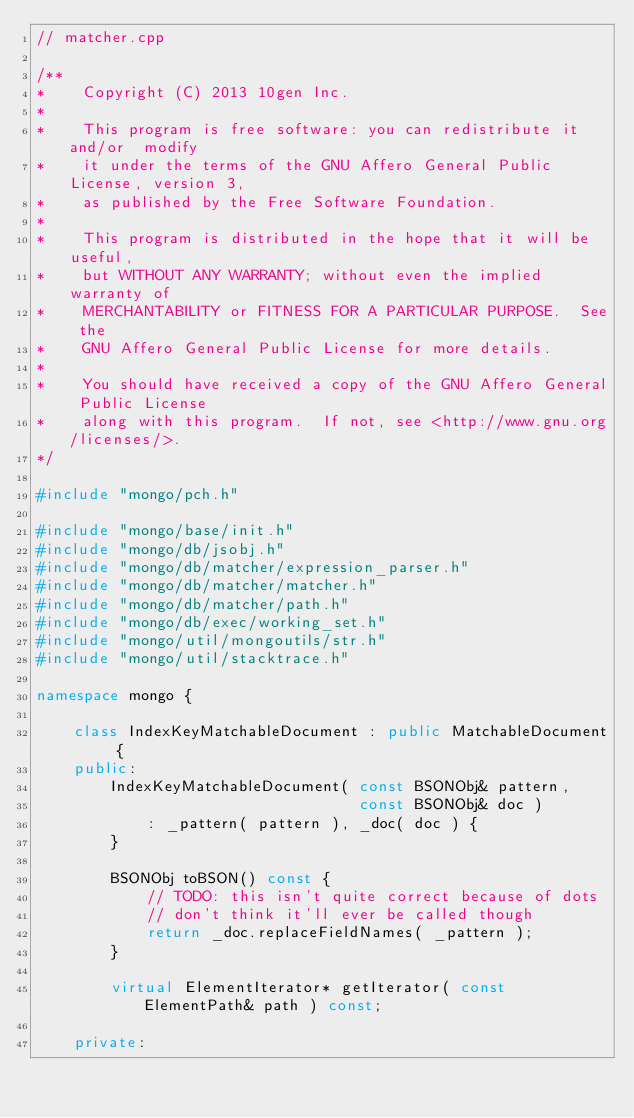<code> <loc_0><loc_0><loc_500><loc_500><_C++_>// matcher.cpp

/**
*    Copyright (C) 2013 10gen Inc.
*
*    This program is free software: you can redistribute it and/or  modify
*    it under the terms of the GNU Affero General Public License, version 3,
*    as published by the Free Software Foundation.
*
*    This program is distributed in the hope that it will be useful,
*    but WITHOUT ANY WARRANTY; without even the implied warranty of
*    MERCHANTABILITY or FITNESS FOR A PARTICULAR PURPOSE.  See the
*    GNU Affero General Public License for more details.
*
*    You should have received a copy of the GNU Affero General Public License
*    along with this program.  If not, see <http://www.gnu.org/licenses/>.
*/

#include "mongo/pch.h"

#include "mongo/base/init.h"
#include "mongo/db/jsobj.h"
#include "mongo/db/matcher/expression_parser.h"
#include "mongo/db/matcher/matcher.h"
#include "mongo/db/matcher/path.h"
#include "mongo/db/exec/working_set.h"
#include "mongo/util/mongoutils/str.h"
#include "mongo/util/stacktrace.h"

namespace mongo {

    class IndexKeyMatchableDocument : public MatchableDocument {
    public:
        IndexKeyMatchableDocument( const BSONObj& pattern,
                                   const BSONObj& doc )
            : _pattern( pattern ), _doc( doc ) {
        }

        BSONObj toBSON() const {
            // TODO: this isn't quite correct because of dots
            // don't think it'll ever be called though
            return _doc.replaceFieldNames( _pattern );
        }

        virtual ElementIterator* getIterator( const ElementPath& path ) const;

    private:
</code> 